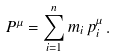<formula> <loc_0><loc_0><loc_500><loc_500>P ^ { \mu } = \sum _ { i = 1 } ^ { n } m _ { i } \, p _ { i } ^ { \mu } \, .</formula> 